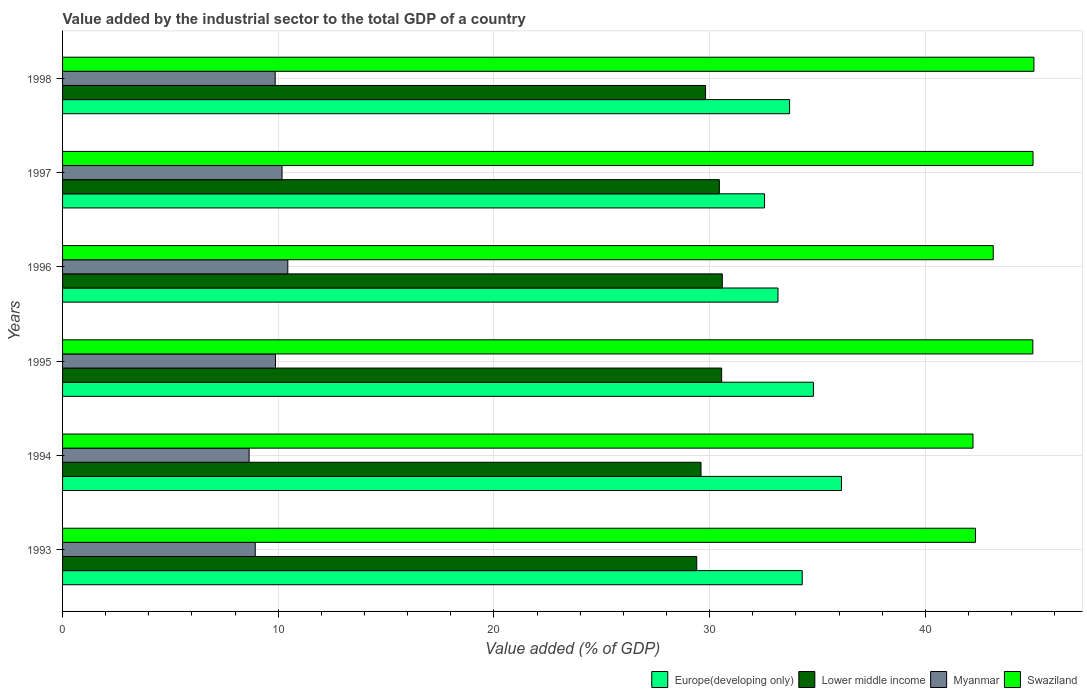How many different coloured bars are there?
Ensure brevity in your answer.  4. Are the number of bars per tick equal to the number of legend labels?
Give a very brief answer. Yes. Are the number of bars on each tick of the Y-axis equal?
Provide a short and direct response. Yes. What is the label of the 1st group of bars from the top?
Make the answer very short. 1998. In how many cases, is the number of bars for a given year not equal to the number of legend labels?
Your response must be concise. 0. What is the value added by the industrial sector to the total GDP in Swaziland in 1994?
Ensure brevity in your answer.  42.21. Across all years, what is the maximum value added by the industrial sector to the total GDP in Lower middle income?
Your answer should be very brief. 30.59. Across all years, what is the minimum value added by the industrial sector to the total GDP in Europe(developing only)?
Provide a succinct answer. 32.54. What is the total value added by the industrial sector to the total GDP in Myanmar in the graph?
Ensure brevity in your answer.  57.93. What is the difference between the value added by the industrial sector to the total GDP in Lower middle income in 1993 and that in 1997?
Provide a short and direct response. -1.05. What is the difference between the value added by the industrial sector to the total GDP in Myanmar in 1993 and the value added by the industrial sector to the total GDP in Lower middle income in 1998?
Make the answer very short. -20.88. What is the average value added by the industrial sector to the total GDP in Europe(developing only) per year?
Provide a short and direct response. 34.11. In the year 1994, what is the difference between the value added by the industrial sector to the total GDP in Swaziland and value added by the industrial sector to the total GDP in Europe(developing only)?
Give a very brief answer. 6.1. What is the ratio of the value added by the industrial sector to the total GDP in Myanmar in 1993 to that in 1995?
Provide a short and direct response. 0.9. What is the difference between the highest and the second highest value added by the industrial sector to the total GDP in Myanmar?
Provide a succinct answer. 0.27. What is the difference between the highest and the lowest value added by the industrial sector to the total GDP in Swaziland?
Offer a terse response. 2.83. In how many years, is the value added by the industrial sector to the total GDP in Europe(developing only) greater than the average value added by the industrial sector to the total GDP in Europe(developing only) taken over all years?
Your answer should be very brief. 3. Is it the case that in every year, the sum of the value added by the industrial sector to the total GDP in Myanmar and value added by the industrial sector to the total GDP in Swaziland is greater than the sum of value added by the industrial sector to the total GDP in Europe(developing only) and value added by the industrial sector to the total GDP in Lower middle income?
Offer a very short reply. No. What does the 4th bar from the top in 1993 represents?
Your answer should be compact. Europe(developing only). What does the 1st bar from the bottom in 1995 represents?
Offer a very short reply. Europe(developing only). How many years are there in the graph?
Provide a succinct answer. 6. What is the difference between two consecutive major ticks on the X-axis?
Keep it short and to the point. 10. Does the graph contain any zero values?
Your answer should be very brief. No. Where does the legend appear in the graph?
Keep it short and to the point. Bottom right. How many legend labels are there?
Offer a terse response. 4. What is the title of the graph?
Offer a terse response. Value added by the industrial sector to the total GDP of a country. What is the label or title of the X-axis?
Make the answer very short. Value added (% of GDP). What is the label or title of the Y-axis?
Your response must be concise. Years. What is the Value added (% of GDP) in Europe(developing only) in 1993?
Offer a very short reply. 34.29. What is the Value added (% of GDP) in Lower middle income in 1993?
Keep it short and to the point. 29.4. What is the Value added (% of GDP) in Myanmar in 1993?
Ensure brevity in your answer.  8.93. What is the Value added (% of GDP) of Swaziland in 1993?
Keep it short and to the point. 42.32. What is the Value added (% of GDP) of Europe(developing only) in 1994?
Ensure brevity in your answer.  36.11. What is the Value added (% of GDP) in Lower middle income in 1994?
Offer a very short reply. 29.6. What is the Value added (% of GDP) in Myanmar in 1994?
Your response must be concise. 8.65. What is the Value added (% of GDP) in Swaziland in 1994?
Give a very brief answer. 42.21. What is the Value added (% of GDP) of Europe(developing only) in 1995?
Offer a very short reply. 34.81. What is the Value added (% of GDP) of Lower middle income in 1995?
Give a very brief answer. 30.56. What is the Value added (% of GDP) of Myanmar in 1995?
Make the answer very short. 9.87. What is the Value added (% of GDP) in Swaziland in 1995?
Offer a terse response. 44.98. What is the Value added (% of GDP) of Europe(developing only) in 1996?
Ensure brevity in your answer.  33.17. What is the Value added (% of GDP) in Lower middle income in 1996?
Provide a short and direct response. 30.59. What is the Value added (% of GDP) in Myanmar in 1996?
Make the answer very short. 10.44. What is the Value added (% of GDP) of Swaziland in 1996?
Give a very brief answer. 43.15. What is the Value added (% of GDP) in Europe(developing only) in 1997?
Your answer should be very brief. 32.54. What is the Value added (% of GDP) in Lower middle income in 1997?
Your response must be concise. 30.45. What is the Value added (% of GDP) in Myanmar in 1997?
Your answer should be very brief. 10.18. What is the Value added (% of GDP) of Swaziland in 1997?
Offer a terse response. 44.99. What is the Value added (% of GDP) of Europe(developing only) in 1998?
Your answer should be very brief. 33.71. What is the Value added (% of GDP) in Lower middle income in 1998?
Ensure brevity in your answer.  29.81. What is the Value added (% of GDP) in Myanmar in 1998?
Give a very brief answer. 9.86. What is the Value added (% of GDP) in Swaziland in 1998?
Make the answer very short. 45.03. Across all years, what is the maximum Value added (% of GDP) of Europe(developing only)?
Offer a very short reply. 36.11. Across all years, what is the maximum Value added (% of GDP) in Lower middle income?
Provide a succinct answer. 30.59. Across all years, what is the maximum Value added (% of GDP) in Myanmar?
Your response must be concise. 10.44. Across all years, what is the maximum Value added (% of GDP) in Swaziland?
Provide a short and direct response. 45.03. Across all years, what is the minimum Value added (% of GDP) in Europe(developing only)?
Provide a short and direct response. 32.54. Across all years, what is the minimum Value added (% of GDP) of Lower middle income?
Keep it short and to the point. 29.4. Across all years, what is the minimum Value added (% of GDP) of Myanmar?
Provide a succinct answer. 8.65. Across all years, what is the minimum Value added (% of GDP) in Swaziland?
Your response must be concise. 42.21. What is the total Value added (% of GDP) in Europe(developing only) in the graph?
Your answer should be compact. 204.63. What is the total Value added (% of GDP) of Lower middle income in the graph?
Your answer should be compact. 180.4. What is the total Value added (% of GDP) in Myanmar in the graph?
Provide a succinct answer. 57.93. What is the total Value added (% of GDP) in Swaziland in the graph?
Ensure brevity in your answer.  262.69. What is the difference between the Value added (% of GDP) in Europe(developing only) in 1993 and that in 1994?
Your answer should be compact. -1.82. What is the difference between the Value added (% of GDP) in Lower middle income in 1993 and that in 1994?
Keep it short and to the point. -0.2. What is the difference between the Value added (% of GDP) of Myanmar in 1993 and that in 1994?
Your response must be concise. 0.28. What is the difference between the Value added (% of GDP) in Swaziland in 1993 and that in 1994?
Your answer should be very brief. 0.11. What is the difference between the Value added (% of GDP) of Europe(developing only) in 1993 and that in 1995?
Ensure brevity in your answer.  -0.52. What is the difference between the Value added (% of GDP) in Lower middle income in 1993 and that in 1995?
Offer a terse response. -1.16. What is the difference between the Value added (% of GDP) in Myanmar in 1993 and that in 1995?
Provide a short and direct response. -0.94. What is the difference between the Value added (% of GDP) in Swaziland in 1993 and that in 1995?
Your response must be concise. -2.66. What is the difference between the Value added (% of GDP) in Europe(developing only) in 1993 and that in 1996?
Provide a succinct answer. 1.12. What is the difference between the Value added (% of GDP) in Lower middle income in 1993 and that in 1996?
Your response must be concise. -1.18. What is the difference between the Value added (% of GDP) in Myanmar in 1993 and that in 1996?
Make the answer very short. -1.51. What is the difference between the Value added (% of GDP) in Swaziland in 1993 and that in 1996?
Provide a short and direct response. -0.82. What is the difference between the Value added (% of GDP) in Europe(developing only) in 1993 and that in 1997?
Provide a short and direct response. 1.75. What is the difference between the Value added (% of GDP) of Lower middle income in 1993 and that in 1997?
Ensure brevity in your answer.  -1.05. What is the difference between the Value added (% of GDP) in Myanmar in 1993 and that in 1997?
Your answer should be very brief. -1.24. What is the difference between the Value added (% of GDP) in Swaziland in 1993 and that in 1997?
Ensure brevity in your answer.  -2.67. What is the difference between the Value added (% of GDP) of Europe(developing only) in 1993 and that in 1998?
Give a very brief answer. 0.59. What is the difference between the Value added (% of GDP) of Lower middle income in 1993 and that in 1998?
Give a very brief answer. -0.41. What is the difference between the Value added (% of GDP) in Myanmar in 1993 and that in 1998?
Give a very brief answer. -0.93. What is the difference between the Value added (% of GDP) of Swaziland in 1993 and that in 1998?
Make the answer very short. -2.71. What is the difference between the Value added (% of GDP) of Europe(developing only) in 1994 and that in 1995?
Your answer should be very brief. 1.3. What is the difference between the Value added (% of GDP) of Lower middle income in 1994 and that in 1995?
Give a very brief answer. -0.96. What is the difference between the Value added (% of GDP) in Myanmar in 1994 and that in 1995?
Provide a short and direct response. -1.22. What is the difference between the Value added (% of GDP) of Swaziland in 1994 and that in 1995?
Keep it short and to the point. -2.77. What is the difference between the Value added (% of GDP) of Europe(developing only) in 1994 and that in 1996?
Your response must be concise. 2.94. What is the difference between the Value added (% of GDP) in Lower middle income in 1994 and that in 1996?
Provide a succinct answer. -0.99. What is the difference between the Value added (% of GDP) of Myanmar in 1994 and that in 1996?
Ensure brevity in your answer.  -1.79. What is the difference between the Value added (% of GDP) of Swaziland in 1994 and that in 1996?
Make the answer very short. -0.94. What is the difference between the Value added (% of GDP) in Europe(developing only) in 1994 and that in 1997?
Provide a succinct answer. 3.57. What is the difference between the Value added (% of GDP) in Lower middle income in 1994 and that in 1997?
Provide a short and direct response. -0.85. What is the difference between the Value added (% of GDP) of Myanmar in 1994 and that in 1997?
Offer a terse response. -1.53. What is the difference between the Value added (% of GDP) in Swaziland in 1994 and that in 1997?
Make the answer very short. -2.78. What is the difference between the Value added (% of GDP) in Europe(developing only) in 1994 and that in 1998?
Your answer should be very brief. 2.41. What is the difference between the Value added (% of GDP) of Lower middle income in 1994 and that in 1998?
Ensure brevity in your answer.  -0.21. What is the difference between the Value added (% of GDP) in Myanmar in 1994 and that in 1998?
Offer a terse response. -1.21. What is the difference between the Value added (% of GDP) in Swaziland in 1994 and that in 1998?
Your response must be concise. -2.83. What is the difference between the Value added (% of GDP) of Europe(developing only) in 1995 and that in 1996?
Give a very brief answer. 1.64. What is the difference between the Value added (% of GDP) of Lower middle income in 1995 and that in 1996?
Ensure brevity in your answer.  -0.03. What is the difference between the Value added (% of GDP) in Myanmar in 1995 and that in 1996?
Ensure brevity in your answer.  -0.57. What is the difference between the Value added (% of GDP) in Swaziland in 1995 and that in 1996?
Keep it short and to the point. 1.84. What is the difference between the Value added (% of GDP) in Europe(developing only) in 1995 and that in 1997?
Offer a very short reply. 2.27. What is the difference between the Value added (% of GDP) of Lower middle income in 1995 and that in 1997?
Make the answer very short. 0.11. What is the difference between the Value added (% of GDP) in Myanmar in 1995 and that in 1997?
Make the answer very short. -0.3. What is the difference between the Value added (% of GDP) in Swaziland in 1995 and that in 1997?
Keep it short and to the point. -0.01. What is the difference between the Value added (% of GDP) of Europe(developing only) in 1995 and that in 1998?
Give a very brief answer. 1.11. What is the difference between the Value added (% of GDP) of Lower middle income in 1995 and that in 1998?
Provide a short and direct response. 0.75. What is the difference between the Value added (% of GDP) of Myanmar in 1995 and that in 1998?
Your response must be concise. 0.01. What is the difference between the Value added (% of GDP) in Swaziland in 1995 and that in 1998?
Give a very brief answer. -0.05. What is the difference between the Value added (% of GDP) in Europe(developing only) in 1996 and that in 1997?
Make the answer very short. 0.62. What is the difference between the Value added (% of GDP) of Lower middle income in 1996 and that in 1997?
Provide a succinct answer. 0.14. What is the difference between the Value added (% of GDP) in Myanmar in 1996 and that in 1997?
Your answer should be compact. 0.27. What is the difference between the Value added (% of GDP) in Swaziland in 1996 and that in 1997?
Your answer should be compact. -1.85. What is the difference between the Value added (% of GDP) in Europe(developing only) in 1996 and that in 1998?
Give a very brief answer. -0.54. What is the difference between the Value added (% of GDP) of Lower middle income in 1996 and that in 1998?
Your answer should be compact. 0.78. What is the difference between the Value added (% of GDP) of Myanmar in 1996 and that in 1998?
Give a very brief answer. 0.58. What is the difference between the Value added (% of GDP) of Swaziland in 1996 and that in 1998?
Keep it short and to the point. -1.89. What is the difference between the Value added (% of GDP) of Europe(developing only) in 1997 and that in 1998?
Your answer should be compact. -1.16. What is the difference between the Value added (% of GDP) of Lower middle income in 1997 and that in 1998?
Your answer should be compact. 0.64. What is the difference between the Value added (% of GDP) of Myanmar in 1997 and that in 1998?
Offer a very short reply. 0.32. What is the difference between the Value added (% of GDP) of Swaziland in 1997 and that in 1998?
Ensure brevity in your answer.  -0.04. What is the difference between the Value added (% of GDP) of Europe(developing only) in 1993 and the Value added (% of GDP) of Lower middle income in 1994?
Provide a succinct answer. 4.69. What is the difference between the Value added (% of GDP) in Europe(developing only) in 1993 and the Value added (% of GDP) in Myanmar in 1994?
Keep it short and to the point. 25.64. What is the difference between the Value added (% of GDP) in Europe(developing only) in 1993 and the Value added (% of GDP) in Swaziland in 1994?
Your answer should be compact. -7.92. What is the difference between the Value added (% of GDP) of Lower middle income in 1993 and the Value added (% of GDP) of Myanmar in 1994?
Offer a very short reply. 20.75. What is the difference between the Value added (% of GDP) in Lower middle income in 1993 and the Value added (% of GDP) in Swaziland in 1994?
Offer a very short reply. -12.81. What is the difference between the Value added (% of GDP) of Myanmar in 1993 and the Value added (% of GDP) of Swaziland in 1994?
Give a very brief answer. -33.28. What is the difference between the Value added (% of GDP) of Europe(developing only) in 1993 and the Value added (% of GDP) of Lower middle income in 1995?
Your response must be concise. 3.74. What is the difference between the Value added (% of GDP) of Europe(developing only) in 1993 and the Value added (% of GDP) of Myanmar in 1995?
Ensure brevity in your answer.  24.42. What is the difference between the Value added (% of GDP) in Europe(developing only) in 1993 and the Value added (% of GDP) in Swaziland in 1995?
Ensure brevity in your answer.  -10.69. What is the difference between the Value added (% of GDP) in Lower middle income in 1993 and the Value added (% of GDP) in Myanmar in 1995?
Ensure brevity in your answer.  19.53. What is the difference between the Value added (% of GDP) of Lower middle income in 1993 and the Value added (% of GDP) of Swaziland in 1995?
Give a very brief answer. -15.58. What is the difference between the Value added (% of GDP) of Myanmar in 1993 and the Value added (% of GDP) of Swaziland in 1995?
Offer a terse response. -36.05. What is the difference between the Value added (% of GDP) in Europe(developing only) in 1993 and the Value added (% of GDP) in Lower middle income in 1996?
Give a very brief answer. 3.71. What is the difference between the Value added (% of GDP) in Europe(developing only) in 1993 and the Value added (% of GDP) in Myanmar in 1996?
Provide a short and direct response. 23.85. What is the difference between the Value added (% of GDP) in Europe(developing only) in 1993 and the Value added (% of GDP) in Swaziland in 1996?
Provide a succinct answer. -8.85. What is the difference between the Value added (% of GDP) in Lower middle income in 1993 and the Value added (% of GDP) in Myanmar in 1996?
Provide a succinct answer. 18.96. What is the difference between the Value added (% of GDP) in Lower middle income in 1993 and the Value added (% of GDP) in Swaziland in 1996?
Keep it short and to the point. -13.75. What is the difference between the Value added (% of GDP) in Myanmar in 1993 and the Value added (% of GDP) in Swaziland in 1996?
Your answer should be compact. -34.21. What is the difference between the Value added (% of GDP) of Europe(developing only) in 1993 and the Value added (% of GDP) of Lower middle income in 1997?
Your response must be concise. 3.84. What is the difference between the Value added (% of GDP) in Europe(developing only) in 1993 and the Value added (% of GDP) in Myanmar in 1997?
Offer a terse response. 24.12. What is the difference between the Value added (% of GDP) in Europe(developing only) in 1993 and the Value added (% of GDP) in Swaziland in 1997?
Offer a very short reply. -10.7. What is the difference between the Value added (% of GDP) in Lower middle income in 1993 and the Value added (% of GDP) in Myanmar in 1997?
Give a very brief answer. 19.23. What is the difference between the Value added (% of GDP) of Lower middle income in 1993 and the Value added (% of GDP) of Swaziland in 1997?
Make the answer very short. -15.59. What is the difference between the Value added (% of GDP) in Myanmar in 1993 and the Value added (% of GDP) in Swaziland in 1997?
Provide a short and direct response. -36.06. What is the difference between the Value added (% of GDP) in Europe(developing only) in 1993 and the Value added (% of GDP) in Lower middle income in 1998?
Your response must be concise. 4.48. What is the difference between the Value added (% of GDP) of Europe(developing only) in 1993 and the Value added (% of GDP) of Myanmar in 1998?
Provide a short and direct response. 24.43. What is the difference between the Value added (% of GDP) of Europe(developing only) in 1993 and the Value added (% of GDP) of Swaziland in 1998?
Keep it short and to the point. -10.74. What is the difference between the Value added (% of GDP) of Lower middle income in 1993 and the Value added (% of GDP) of Myanmar in 1998?
Provide a succinct answer. 19.54. What is the difference between the Value added (% of GDP) of Lower middle income in 1993 and the Value added (% of GDP) of Swaziland in 1998?
Ensure brevity in your answer.  -15.63. What is the difference between the Value added (% of GDP) of Myanmar in 1993 and the Value added (% of GDP) of Swaziland in 1998?
Offer a very short reply. -36.1. What is the difference between the Value added (% of GDP) of Europe(developing only) in 1994 and the Value added (% of GDP) of Lower middle income in 1995?
Ensure brevity in your answer.  5.55. What is the difference between the Value added (% of GDP) of Europe(developing only) in 1994 and the Value added (% of GDP) of Myanmar in 1995?
Ensure brevity in your answer.  26.24. What is the difference between the Value added (% of GDP) in Europe(developing only) in 1994 and the Value added (% of GDP) in Swaziland in 1995?
Ensure brevity in your answer.  -8.87. What is the difference between the Value added (% of GDP) in Lower middle income in 1994 and the Value added (% of GDP) in Myanmar in 1995?
Make the answer very short. 19.73. What is the difference between the Value added (% of GDP) in Lower middle income in 1994 and the Value added (% of GDP) in Swaziland in 1995?
Offer a very short reply. -15.38. What is the difference between the Value added (% of GDP) in Myanmar in 1994 and the Value added (% of GDP) in Swaziland in 1995?
Your answer should be very brief. -36.33. What is the difference between the Value added (% of GDP) in Europe(developing only) in 1994 and the Value added (% of GDP) in Lower middle income in 1996?
Your response must be concise. 5.53. What is the difference between the Value added (% of GDP) of Europe(developing only) in 1994 and the Value added (% of GDP) of Myanmar in 1996?
Make the answer very short. 25.67. What is the difference between the Value added (% of GDP) in Europe(developing only) in 1994 and the Value added (% of GDP) in Swaziland in 1996?
Your answer should be compact. -7.04. What is the difference between the Value added (% of GDP) of Lower middle income in 1994 and the Value added (% of GDP) of Myanmar in 1996?
Your response must be concise. 19.16. What is the difference between the Value added (% of GDP) of Lower middle income in 1994 and the Value added (% of GDP) of Swaziland in 1996?
Provide a short and direct response. -13.55. What is the difference between the Value added (% of GDP) in Myanmar in 1994 and the Value added (% of GDP) in Swaziland in 1996?
Your answer should be very brief. -34.5. What is the difference between the Value added (% of GDP) in Europe(developing only) in 1994 and the Value added (% of GDP) in Lower middle income in 1997?
Your response must be concise. 5.66. What is the difference between the Value added (% of GDP) of Europe(developing only) in 1994 and the Value added (% of GDP) of Myanmar in 1997?
Offer a terse response. 25.94. What is the difference between the Value added (% of GDP) in Europe(developing only) in 1994 and the Value added (% of GDP) in Swaziland in 1997?
Your response must be concise. -8.88. What is the difference between the Value added (% of GDP) in Lower middle income in 1994 and the Value added (% of GDP) in Myanmar in 1997?
Your response must be concise. 19.42. What is the difference between the Value added (% of GDP) in Lower middle income in 1994 and the Value added (% of GDP) in Swaziland in 1997?
Give a very brief answer. -15.39. What is the difference between the Value added (% of GDP) in Myanmar in 1994 and the Value added (% of GDP) in Swaziland in 1997?
Your answer should be very brief. -36.34. What is the difference between the Value added (% of GDP) in Europe(developing only) in 1994 and the Value added (% of GDP) in Lower middle income in 1998?
Give a very brief answer. 6.3. What is the difference between the Value added (% of GDP) in Europe(developing only) in 1994 and the Value added (% of GDP) in Myanmar in 1998?
Offer a terse response. 26.25. What is the difference between the Value added (% of GDP) in Europe(developing only) in 1994 and the Value added (% of GDP) in Swaziland in 1998?
Make the answer very short. -8.92. What is the difference between the Value added (% of GDP) of Lower middle income in 1994 and the Value added (% of GDP) of Myanmar in 1998?
Your answer should be very brief. 19.74. What is the difference between the Value added (% of GDP) in Lower middle income in 1994 and the Value added (% of GDP) in Swaziland in 1998?
Make the answer very short. -15.43. What is the difference between the Value added (% of GDP) in Myanmar in 1994 and the Value added (% of GDP) in Swaziland in 1998?
Give a very brief answer. -36.38. What is the difference between the Value added (% of GDP) of Europe(developing only) in 1995 and the Value added (% of GDP) of Lower middle income in 1996?
Keep it short and to the point. 4.22. What is the difference between the Value added (% of GDP) in Europe(developing only) in 1995 and the Value added (% of GDP) in Myanmar in 1996?
Give a very brief answer. 24.37. What is the difference between the Value added (% of GDP) of Europe(developing only) in 1995 and the Value added (% of GDP) of Swaziland in 1996?
Your answer should be very brief. -8.34. What is the difference between the Value added (% of GDP) in Lower middle income in 1995 and the Value added (% of GDP) in Myanmar in 1996?
Offer a terse response. 20.11. What is the difference between the Value added (% of GDP) of Lower middle income in 1995 and the Value added (% of GDP) of Swaziland in 1996?
Provide a succinct answer. -12.59. What is the difference between the Value added (% of GDP) in Myanmar in 1995 and the Value added (% of GDP) in Swaziland in 1996?
Your response must be concise. -33.28. What is the difference between the Value added (% of GDP) of Europe(developing only) in 1995 and the Value added (% of GDP) of Lower middle income in 1997?
Give a very brief answer. 4.36. What is the difference between the Value added (% of GDP) in Europe(developing only) in 1995 and the Value added (% of GDP) in Myanmar in 1997?
Offer a terse response. 24.64. What is the difference between the Value added (% of GDP) of Europe(developing only) in 1995 and the Value added (% of GDP) of Swaziland in 1997?
Your answer should be compact. -10.18. What is the difference between the Value added (% of GDP) in Lower middle income in 1995 and the Value added (% of GDP) in Myanmar in 1997?
Offer a very short reply. 20.38. What is the difference between the Value added (% of GDP) of Lower middle income in 1995 and the Value added (% of GDP) of Swaziland in 1997?
Your response must be concise. -14.44. What is the difference between the Value added (% of GDP) in Myanmar in 1995 and the Value added (% of GDP) in Swaziland in 1997?
Your answer should be very brief. -35.12. What is the difference between the Value added (% of GDP) in Europe(developing only) in 1995 and the Value added (% of GDP) in Lower middle income in 1998?
Provide a succinct answer. 5. What is the difference between the Value added (% of GDP) in Europe(developing only) in 1995 and the Value added (% of GDP) in Myanmar in 1998?
Give a very brief answer. 24.95. What is the difference between the Value added (% of GDP) in Europe(developing only) in 1995 and the Value added (% of GDP) in Swaziland in 1998?
Give a very brief answer. -10.22. What is the difference between the Value added (% of GDP) of Lower middle income in 1995 and the Value added (% of GDP) of Myanmar in 1998?
Offer a very short reply. 20.7. What is the difference between the Value added (% of GDP) of Lower middle income in 1995 and the Value added (% of GDP) of Swaziland in 1998?
Make the answer very short. -14.48. What is the difference between the Value added (% of GDP) in Myanmar in 1995 and the Value added (% of GDP) in Swaziland in 1998?
Provide a short and direct response. -35.16. What is the difference between the Value added (% of GDP) of Europe(developing only) in 1996 and the Value added (% of GDP) of Lower middle income in 1997?
Make the answer very short. 2.72. What is the difference between the Value added (% of GDP) of Europe(developing only) in 1996 and the Value added (% of GDP) of Myanmar in 1997?
Your answer should be compact. 22.99. What is the difference between the Value added (% of GDP) of Europe(developing only) in 1996 and the Value added (% of GDP) of Swaziland in 1997?
Keep it short and to the point. -11.82. What is the difference between the Value added (% of GDP) of Lower middle income in 1996 and the Value added (% of GDP) of Myanmar in 1997?
Provide a succinct answer. 20.41. What is the difference between the Value added (% of GDP) in Lower middle income in 1996 and the Value added (% of GDP) in Swaziland in 1997?
Your response must be concise. -14.41. What is the difference between the Value added (% of GDP) in Myanmar in 1996 and the Value added (% of GDP) in Swaziland in 1997?
Keep it short and to the point. -34.55. What is the difference between the Value added (% of GDP) in Europe(developing only) in 1996 and the Value added (% of GDP) in Lower middle income in 1998?
Make the answer very short. 3.36. What is the difference between the Value added (% of GDP) in Europe(developing only) in 1996 and the Value added (% of GDP) in Myanmar in 1998?
Give a very brief answer. 23.31. What is the difference between the Value added (% of GDP) of Europe(developing only) in 1996 and the Value added (% of GDP) of Swaziland in 1998?
Offer a very short reply. -11.87. What is the difference between the Value added (% of GDP) of Lower middle income in 1996 and the Value added (% of GDP) of Myanmar in 1998?
Provide a succinct answer. 20.73. What is the difference between the Value added (% of GDP) in Lower middle income in 1996 and the Value added (% of GDP) in Swaziland in 1998?
Ensure brevity in your answer.  -14.45. What is the difference between the Value added (% of GDP) of Myanmar in 1996 and the Value added (% of GDP) of Swaziland in 1998?
Make the answer very short. -34.59. What is the difference between the Value added (% of GDP) in Europe(developing only) in 1997 and the Value added (% of GDP) in Lower middle income in 1998?
Keep it short and to the point. 2.73. What is the difference between the Value added (% of GDP) of Europe(developing only) in 1997 and the Value added (% of GDP) of Myanmar in 1998?
Offer a very short reply. 22.69. What is the difference between the Value added (% of GDP) in Europe(developing only) in 1997 and the Value added (% of GDP) in Swaziland in 1998?
Your answer should be very brief. -12.49. What is the difference between the Value added (% of GDP) in Lower middle income in 1997 and the Value added (% of GDP) in Myanmar in 1998?
Your answer should be compact. 20.59. What is the difference between the Value added (% of GDP) of Lower middle income in 1997 and the Value added (% of GDP) of Swaziland in 1998?
Offer a very short reply. -14.58. What is the difference between the Value added (% of GDP) of Myanmar in 1997 and the Value added (% of GDP) of Swaziland in 1998?
Provide a succinct answer. -34.86. What is the average Value added (% of GDP) of Europe(developing only) per year?
Offer a very short reply. 34.11. What is the average Value added (% of GDP) in Lower middle income per year?
Provide a short and direct response. 30.07. What is the average Value added (% of GDP) in Myanmar per year?
Your answer should be compact. 9.65. What is the average Value added (% of GDP) in Swaziland per year?
Keep it short and to the point. 43.78. In the year 1993, what is the difference between the Value added (% of GDP) of Europe(developing only) and Value added (% of GDP) of Lower middle income?
Provide a succinct answer. 4.89. In the year 1993, what is the difference between the Value added (% of GDP) of Europe(developing only) and Value added (% of GDP) of Myanmar?
Give a very brief answer. 25.36. In the year 1993, what is the difference between the Value added (% of GDP) in Europe(developing only) and Value added (% of GDP) in Swaziland?
Provide a succinct answer. -8.03. In the year 1993, what is the difference between the Value added (% of GDP) of Lower middle income and Value added (% of GDP) of Myanmar?
Ensure brevity in your answer.  20.47. In the year 1993, what is the difference between the Value added (% of GDP) of Lower middle income and Value added (% of GDP) of Swaziland?
Give a very brief answer. -12.92. In the year 1993, what is the difference between the Value added (% of GDP) of Myanmar and Value added (% of GDP) of Swaziland?
Offer a terse response. -33.39. In the year 1994, what is the difference between the Value added (% of GDP) of Europe(developing only) and Value added (% of GDP) of Lower middle income?
Provide a succinct answer. 6.51. In the year 1994, what is the difference between the Value added (% of GDP) of Europe(developing only) and Value added (% of GDP) of Myanmar?
Provide a succinct answer. 27.46. In the year 1994, what is the difference between the Value added (% of GDP) of Europe(developing only) and Value added (% of GDP) of Swaziland?
Offer a terse response. -6.1. In the year 1994, what is the difference between the Value added (% of GDP) in Lower middle income and Value added (% of GDP) in Myanmar?
Give a very brief answer. 20.95. In the year 1994, what is the difference between the Value added (% of GDP) of Lower middle income and Value added (% of GDP) of Swaziland?
Give a very brief answer. -12.61. In the year 1994, what is the difference between the Value added (% of GDP) of Myanmar and Value added (% of GDP) of Swaziland?
Give a very brief answer. -33.56. In the year 1995, what is the difference between the Value added (% of GDP) of Europe(developing only) and Value added (% of GDP) of Lower middle income?
Provide a short and direct response. 4.25. In the year 1995, what is the difference between the Value added (% of GDP) in Europe(developing only) and Value added (% of GDP) in Myanmar?
Offer a very short reply. 24.94. In the year 1995, what is the difference between the Value added (% of GDP) of Europe(developing only) and Value added (% of GDP) of Swaziland?
Offer a very short reply. -10.17. In the year 1995, what is the difference between the Value added (% of GDP) of Lower middle income and Value added (% of GDP) of Myanmar?
Give a very brief answer. 20.69. In the year 1995, what is the difference between the Value added (% of GDP) of Lower middle income and Value added (% of GDP) of Swaziland?
Keep it short and to the point. -14.43. In the year 1995, what is the difference between the Value added (% of GDP) of Myanmar and Value added (% of GDP) of Swaziland?
Ensure brevity in your answer.  -35.11. In the year 1996, what is the difference between the Value added (% of GDP) of Europe(developing only) and Value added (% of GDP) of Lower middle income?
Provide a succinct answer. 2.58. In the year 1996, what is the difference between the Value added (% of GDP) of Europe(developing only) and Value added (% of GDP) of Myanmar?
Make the answer very short. 22.73. In the year 1996, what is the difference between the Value added (% of GDP) of Europe(developing only) and Value added (% of GDP) of Swaziland?
Provide a short and direct response. -9.98. In the year 1996, what is the difference between the Value added (% of GDP) in Lower middle income and Value added (% of GDP) in Myanmar?
Provide a short and direct response. 20.14. In the year 1996, what is the difference between the Value added (% of GDP) in Lower middle income and Value added (% of GDP) in Swaziland?
Your response must be concise. -12.56. In the year 1996, what is the difference between the Value added (% of GDP) in Myanmar and Value added (% of GDP) in Swaziland?
Give a very brief answer. -32.7. In the year 1997, what is the difference between the Value added (% of GDP) in Europe(developing only) and Value added (% of GDP) in Lower middle income?
Your answer should be very brief. 2.09. In the year 1997, what is the difference between the Value added (% of GDP) of Europe(developing only) and Value added (% of GDP) of Myanmar?
Your answer should be very brief. 22.37. In the year 1997, what is the difference between the Value added (% of GDP) of Europe(developing only) and Value added (% of GDP) of Swaziland?
Offer a terse response. -12.45. In the year 1997, what is the difference between the Value added (% of GDP) in Lower middle income and Value added (% of GDP) in Myanmar?
Your answer should be compact. 20.27. In the year 1997, what is the difference between the Value added (% of GDP) in Lower middle income and Value added (% of GDP) in Swaziland?
Ensure brevity in your answer.  -14.54. In the year 1997, what is the difference between the Value added (% of GDP) of Myanmar and Value added (% of GDP) of Swaziland?
Make the answer very short. -34.82. In the year 1998, what is the difference between the Value added (% of GDP) of Europe(developing only) and Value added (% of GDP) of Lower middle income?
Make the answer very short. 3.89. In the year 1998, what is the difference between the Value added (% of GDP) in Europe(developing only) and Value added (% of GDP) in Myanmar?
Give a very brief answer. 23.85. In the year 1998, what is the difference between the Value added (% of GDP) of Europe(developing only) and Value added (% of GDP) of Swaziland?
Your answer should be very brief. -11.33. In the year 1998, what is the difference between the Value added (% of GDP) of Lower middle income and Value added (% of GDP) of Myanmar?
Offer a very short reply. 19.95. In the year 1998, what is the difference between the Value added (% of GDP) of Lower middle income and Value added (% of GDP) of Swaziland?
Make the answer very short. -15.22. In the year 1998, what is the difference between the Value added (% of GDP) of Myanmar and Value added (% of GDP) of Swaziland?
Give a very brief answer. -35.18. What is the ratio of the Value added (% of GDP) of Europe(developing only) in 1993 to that in 1994?
Provide a short and direct response. 0.95. What is the ratio of the Value added (% of GDP) in Lower middle income in 1993 to that in 1994?
Your answer should be compact. 0.99. What is the ratio of the Value added (% of GDP) of Myanmar in 1993 to that in 1994?
Ensure brevity in your answer.  1.03. What is the ratio of the Value added (% of GDP) in Europe(developing only) in 1993 to that in 1995?
Your response must be concise. 0.99. What is the ratio of the Value added (% of GDP) of Lower middle income in 1993 to that in 1995?
Your answer should be compact. 0.96. What is the ratio of the Value added (% of GDP) in Myanmar in 1993 to that in 1995?
Keep it short and to the point. 0.9. What is the ratio of the Value added (% of GDP) in Swaziland in 1993 to that in 1995?
Your response must be concise. 0.94. What is the ratio of the Value added (% of GDP) of Europe(developing only) in 1993 to that in 1996?
Provide a short and direct response. 1.03. What is the ratio of the Value added (% of GDP) of Lower middle income in 1993 to that in 1996?
Provide a short and direct response. 0.96. What is the ratio of the Value added (% of GDP) in Myanmar in 1993 to that in 1996?
Provide a short and direct response. 0.86. What is the ratio of the Value added (% of GDP) in Swaziland in 1993 to that in 1996?
Keep it short and to the point. 0.98. What is the ratio of the Value added (% of GDP) in Europe(developing only) in 1993 to that in 1997?
Your answer should be very brief. 1.05. What is the ratio of the Value added (% of GDP) of Lower middle income in 1993 to that in 1997?
Offer a very short reply. 0.97. What is the ratio of the Value added (% of GDP) in Myanmar in 1993 to that in 1997?
Provide a short and direct response. 0.88. What is the ratio of the Value added (% of GDP) of Swaziland in 1993 to that in 1997?
Your answer should be compact. 0.94. What is the ratio of the Value added (% of GDP) in Europe(developing only) in 1993 to that in 1998?
Provide a succinct answer. 1.02. What is the ratio of the Value added (% of GDP) of Lower middle income in 1993 to that in 1998?
Make the answer very short. 0.99. What is the ratio of the Value added (% of GDP) of Myanmar in 1993 to that in 1998?
Provide a succinct answer. 0.91. What is the ratio of the Value added (% of GDP) of Swaziland in 1993 to that in 1998?
Make the answer very short. 0.94. What is the ratio of the Value added (% of GDP) in Europe(developing only) in 1994 to that in 1995?
Offer a terse response. 1.04. What is the ratio of the Value added (% of GDP) of Lower middle income in 1994 to that in 1995?
Your answer should be compact. 0.97. What is the ratio of the Value added (% of GDP) of Myanmar in 1994 to that in 1995?
Your response must be concise. 0.88. What is the ratio of the Value added (% of GDP) in Swaziland in 1994 to that in 1995?
Make the answer very short. 0.94. What is the ratio of the Value added (% of GDP) of Europe(developing only) in 1994 to that in 1996?
Provide a succinct answer. 1.09. What is the ratio of the Value added (% of GDP) in Lower middle income in 1994 to that in 1996?
Your answer should be very brief. 0.97. What is the ratio of the Value added (% of GDP) of Myanmar in 1994 to that in 1996?
Keep it short and to the point. 0.83. What is the ratio of the Value added (% of GDP) of Swaziland in 1994 to that in 1996?
Your answer should be compact. 0.98. What is the ratio of the Value added (% of GDP) of Europe(developing only) in 1994 to that in 1997?
Offer a very short reply. 1.11. What is the ratio of the Value added (% of GDP) of Lower middle income in 1994 to that in 1997?
Make the answer very short. 0.97. What is the ratio of the Value added (% of GDP) in Swaziland in 1994 to that in 1997?
Give a very brief answer. 0.94. What is the ratio of the Value added (% of GDP) of Europe(developing only) in 1994 to that in 1998?
Keep it short and to the point. 1.07. What is the ratio of the Value added (% of GDP) in Lower middle income in 1994 to that in 1998?
Your response must be concise. 0.99. What is the ratio of the Value added (% of GDP) of Myanmar in 1994 to that in 1998?
Make the answer very short. 0.88. What is the ratio of the Value added (% of GDP) in Swaziland in 1994 to that in 1998?
Your answer should be very brief. 0.94. What is the ratio of the Value added (% of GDP) of Europe(developing only) in 1995 to that in 1996?
Provide a succinct answer. 1.05. What is the ratio of the Value added (% of GDP) in Lower middle income in 1995 to that in 1996?
Give a very brief answer. 1. What is the ratio of the Value added (% of GDP) in Myanmar in 1995 to that in 1996?
Offer a terse response. 0.95. What is the ratio of the Value added (% of GDP) in Swaziland in 1995 to that in 1996?
Offer a terse response. 1.04. What is the ratio of the Value added (% of GDP) of Europe(developing only) in 1995 to that in 1997?
Your answer should be compact. 1.07. What is the ratio of the Value added (% of GDP) in Lower middle income in 1995 to that in 1997?
Provide a succinct answer. 1. What is the ratio of the Value added (% of GDP) in Myanmar in 1995 to that in 1997?
Offer a very short reply. 0.97. What is the ratio of the Value added (% of GDP) of Swaziland in 1995 to that in 1997?
Your answer should be very brief. 1. What is the ratio of the Value added (% of GDP) in Europe(developing only) in 1995 to that in 1998?
Provide a short and direct response. 1.03. What is the ratio of the Value added (% of GDP) in Lower middle income in 1995 to that in 1998?
Your response must be concise. 1.02. What is the ratio of the Value added (% of GDP) of Myanmar in 1995 to that in 1998?
Offer a terse response. 1. What is the ratio of the Value added (% of GDP) of Europe(developing only) in 1996 to that in 1997?
Your answer should be compact. 1.02. What is the ratio of the Value added (% of GDP) of Lower middle income in 1996 to that in 1997?
Provide a short and direct response. 1. What is the ratio of the Value added (% of GDP) of Myanmar in 1996 to that in 1997?
Make the answer very short. 1.03. What is the ratio of the Value added (% of GDP) of Swaziland in 1996 to that in 1997?
Offer a terse response. 0.96. What is the ratio of the Value added (% of GDP) of Europe(developing only) in 1996 to that in 1998?
Ensure brevity in your answer.  0.98. What is the ratio of the Value added (% of GDP) in Lower middle income in 1996 to that in 1998?
Make the answer very short. 1.03. What is the ratio of the Value added (% of GDP) in Myanmar in 1996 to that in 1998?
Provide a succinct answer. 1.06. What is the ratio of the Value added (% of GDP) of Swaziland in 1996 to that in 1998?
Give a very brief answer. 0.96. What is the ratio of the Value added (% of GDP) of Europe(developing only) in 1997 to that in 1998?
Keep it short and to the point. 0.97. What is the ratio of the Value added (% of GDP) in Lower middle income in 1997 to that in 1998?
Offer a very short reply. 1.02. What is the ratio of the Value added (% of GDP) in Myanmar in 1997 to that in 1998?
Provide a succinct answer. 1.03. What is the difference between the highest and the second highest Value added (% of GDP) in Europe(developing only)?
Your answer should be compact. 1.3. What is the difference between the highest and the second highest Value added (% of GDP) of Lower middle income?
Offer a terse response. 0.03. What is the difference between the highest and the second highest Value added (% of GDP) of Myanmar?
Ensure brevity in your answer.  0.27. What is the difference between the highest and the second highest Value added (% of GDP) of Swaziland?
Offer a terse response. 0.04. What is the difference between the highest and the lowest Value added (% of GDP) of Europe(developing only)?
Make the answer very short. 3.57. What is the difference between the highest and the lowest Value added (% of GDP) of Lower middle income?
Provide a succinct answer. 1.18. What is the difference between the highest and the lowest Value added (% of GDP) in Myanmar?
Offer a very short reply. 1.79. What is the difference between the highest and the lowest Value added (% of GDP) in Swaziland?
Offer a terse response. 2.83. 